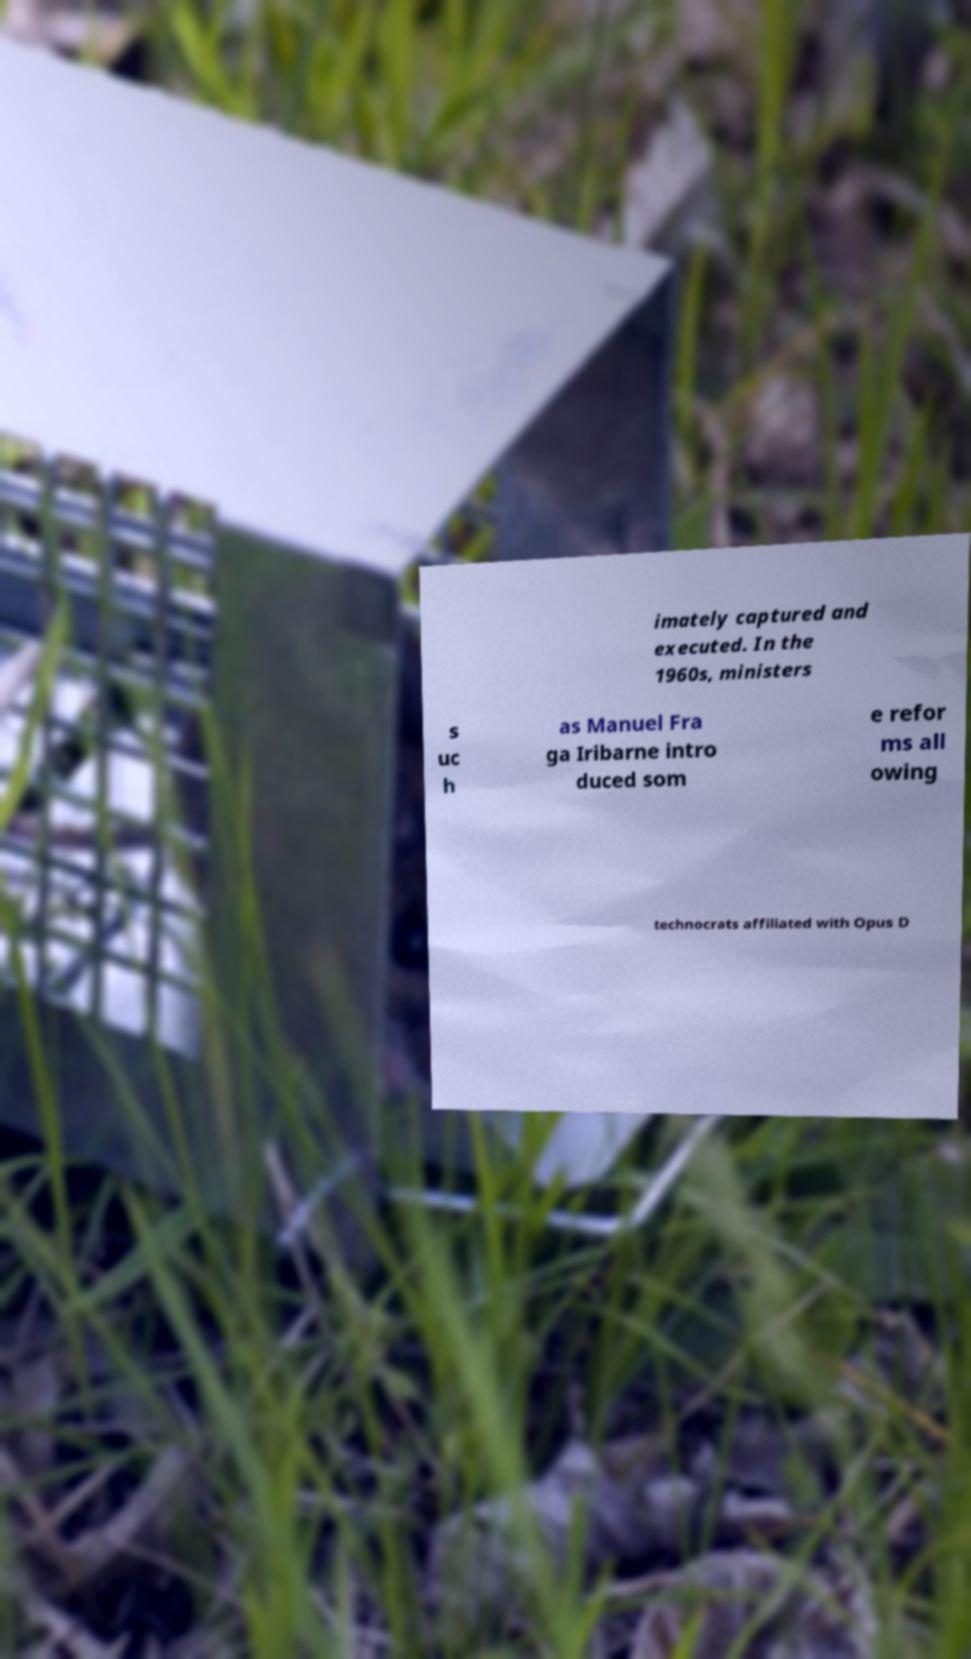Can you accurately transcribe the text from the provided image for me? imately captured and executed. In the 1960s, ministers s uc h as Manuel Fra ga Iribarne intro duced som e refor ms all owing technocrats affiliated with Opus D 